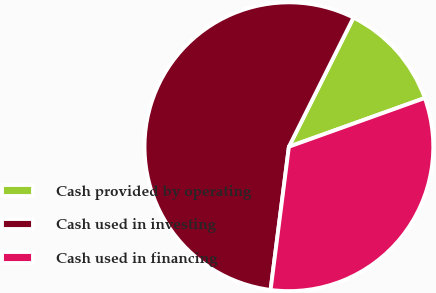Convert chart to OTSL. <chart><loc_0><loc_0><loc_500><loc_500><pie_chart><fcel>Cash provided by operating<fcel>Cash used in investing<fcel>Cash used in financing<nl><fcel>12.14%<fcel>55.36%<fcel>32.51%<nl></chart> 